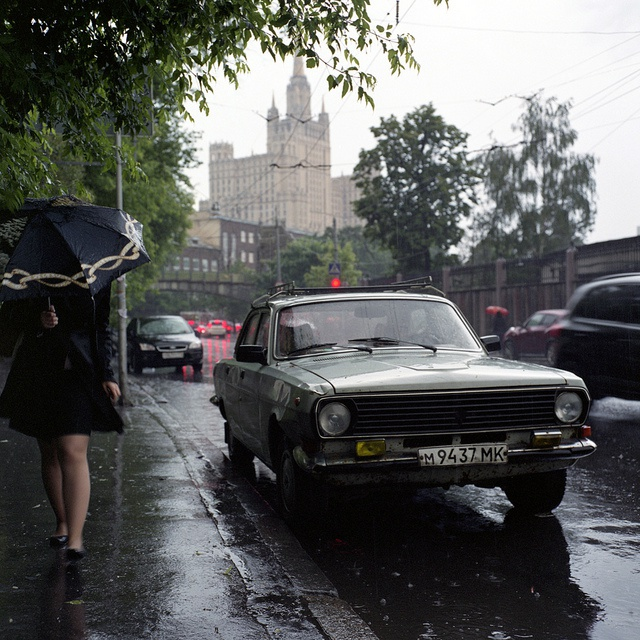Describe the objects in this image and their specific colors. I can see car in black, darkgray, gray, and lightgray tones, people in black and gray tones, umbrella in black, gray, and darkgray tones, car in black, gray, and darkgray tones, and car in black, gray, darkgray, and lightgray tones in this image. 